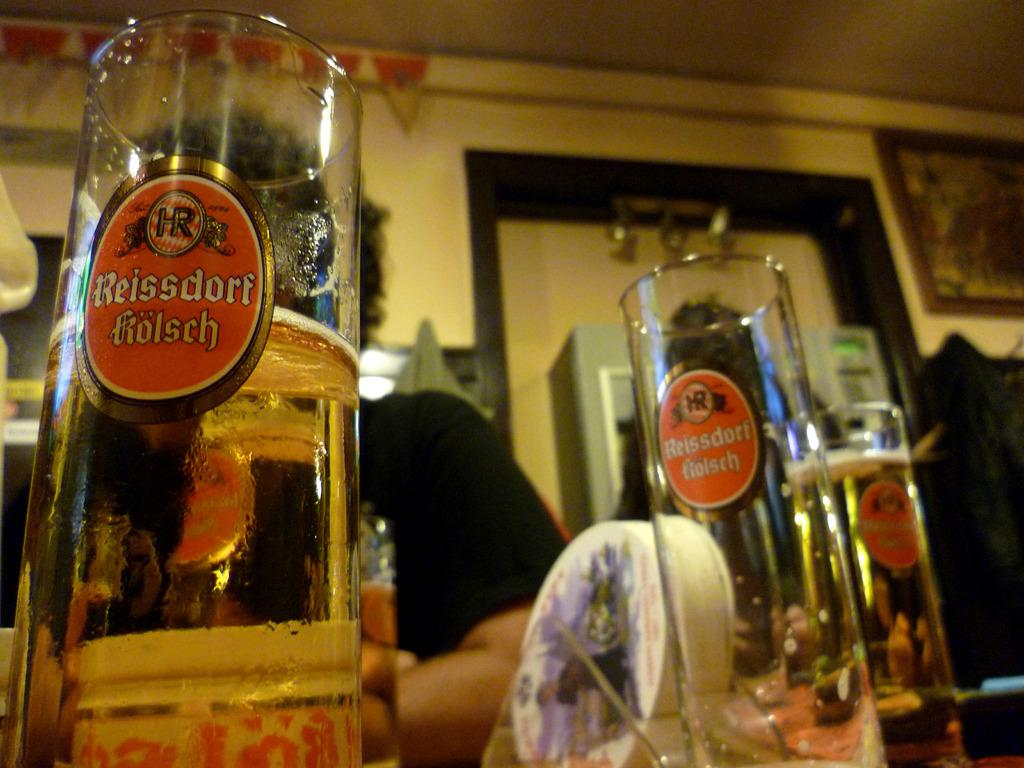<image>
Create a compact narrative representing the image presented. One Reissdorf kolsch glass is empty but the other two are full or almost full. 